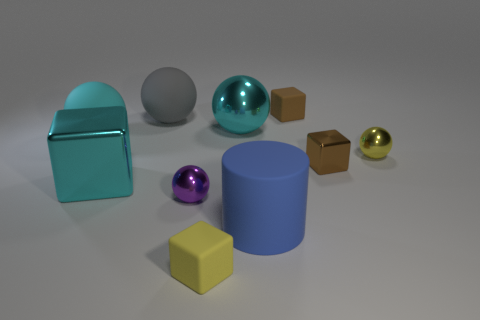Subtract 1 blocks. How many blocks are left? 3 Subtract all yellow spheres. How many spheres are left? 4 Subtract all brown balls. Subtract all red blocks. How many balls are left? 5 Subtract all cylinders. How many objects are left? 9 Subtract 0 purple cylinders. How many objects are left? 10 Subtract all big cyan matte cylinders. Subtract all big balls. How many objects are left? 7 Add 3 small yellow rubber cubes. How many small yellow rubber cubes are left? 4 Add 4 yellow metal cylinders. How many yellow metal cylinders exist? 4 